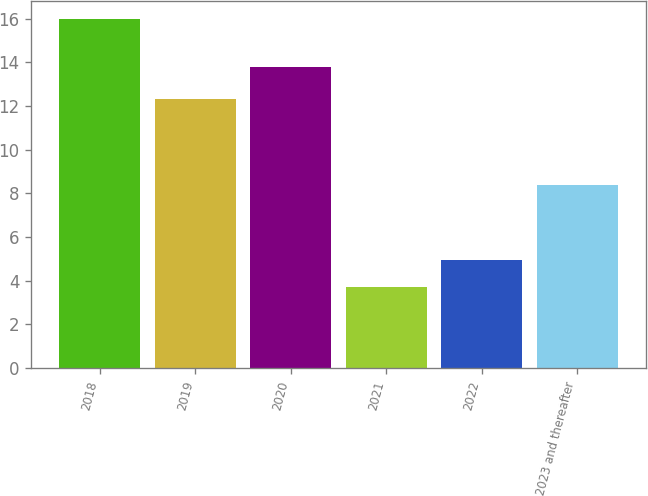Convert chart to OTSL. <chart><loc_0><loc_0><loc_500><loc_500><bar_chart><fcel>2018<fcel>2019<fcel>2020<fcel>2021<fcel>2022<fcel>2023 and thereafter<nl><fcel>16<fcel>12.3<fcel>13.8<fcel>3.7<fcel>4.93<fcel>8.4<nl></chart> 